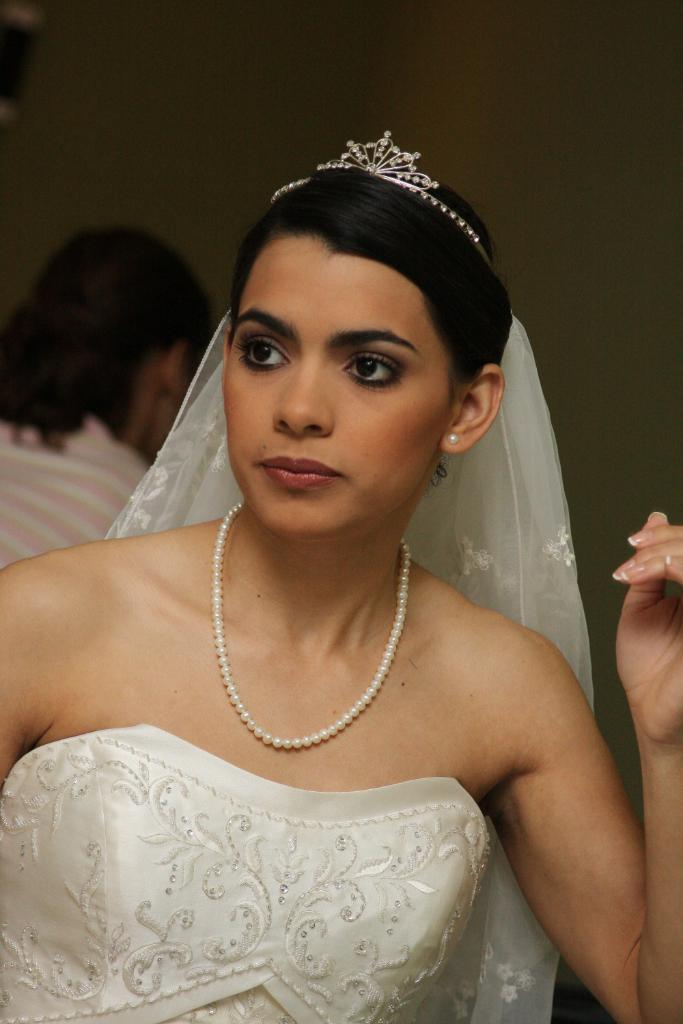What is the woman in the image wearing? The woman in the image is wearing a bridal dress. Can you describe the person sitting behind the woman? Unfortunately, the person sitting behind the woman is not visible due to the blurred background. What can be said about the background of the image? The background of the image is blurred. What type of bushes can be seen in the image? There are no bushes visible in the image. Is the woman in the image a spy? There is no indication in the image that the woman is a spy. 